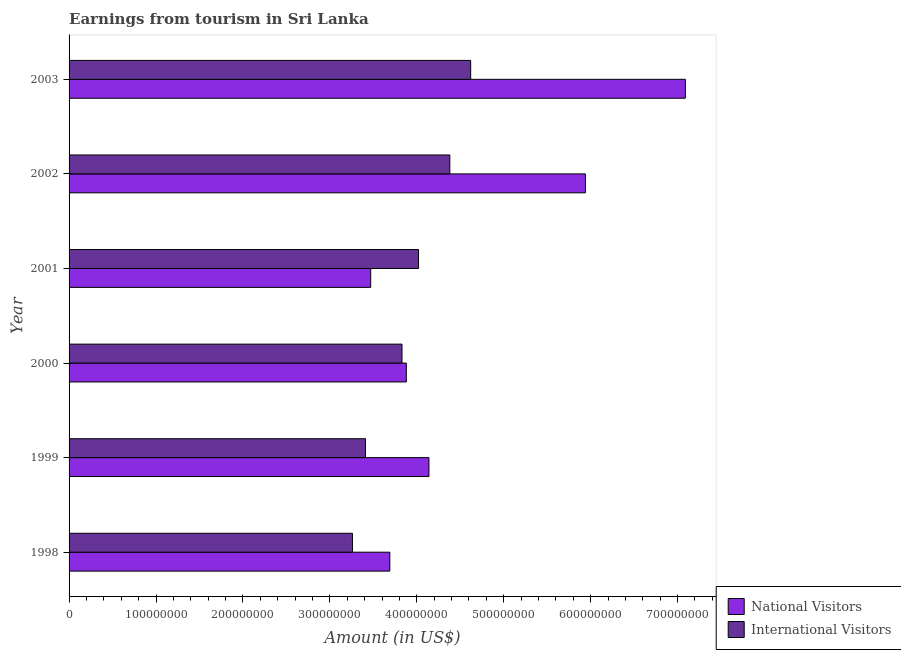How many different coloured bars are there?
Offer a terse response. 2. Are the number of bars per tick equal to the number of legend labels?
Provide a short and direct response. Yes. How many bars are there on the 3rd tick from the top?
Your answer should be very brief. 2. How many bars are there on the 2nd tick from the bottom?
Your answer should be compact. 2. What is the label of the 3rd group of bars from the top?
Your answer should be compact. 2001. What is the amount earned from international visitors in 2003?
Provide a succinct answer. 4.62e+08. Across all years, what is the maximum amount earned from international visitors?
Provide a succinct answer. 4.62e+08. Across all years, what is the minimum amount earned from international visitors?
Provide a short and direct response. 3.26e+08. In which year was the amount earned from national visitors maximum?
Make the answer very short. 2003. In which year was the amount earned from international visitors minimum?
Keep it short and to the point. 1998. What is the total amount earned from international visitors in the graph?
Give a very brief answer. 2.35e+09. What is the difference between the amount earned from international visitors in 2000 and that in 2001?
Provide a short and direct response. -1.90e+07. What is the difference between the amount earned from national visitors in 2003 and the amount earned from international visitors in 1998?
Give a very brief answer. 3.83e+08. What is the average amount earned from national visitors per year?
Give a very brief answer. 4.70e+08. In the year 2000, what is the difference between the amount earned from national visitors and amount earned from international visitors?
Make the answer very short. 5.00e+06. What is the ratio of the amount earned from national visitors in 1998 to that in 2001?
Your answer should be compact. 1.06. Is the amount earned from international visitors in 1998 less than that in 2001?
Give a very brief answer. Yes. Is the difference between the amount earned from international visitors in 2001 and 2003 greater than the difference between the amount earned from national visitors in 2001 and 2003?
Provide a succinct answer. Yes. What is the difference between the highest and the second highest amount earned from international visitors?
Your answer should be very brief. 2.40e+07. What is the difference between the highest and the lowest amount earned from national visitors?
Keep it short and to the point. 3.62e+08. Is the sum of the amount earned from international visitors in 2000 and 2001 greater than the maximum amount earned from national visitors across all years?
Offer a terse response. Yes. What does the 1st bar from the top in 2002 represents?
Ensure brevity in your answer.  International Visitors. What does the 2nd bar from the bottom in 2003 represents?
Give a very brief answer. International Visitors. Are all the bars in the graph horizontal?
Offer a very short reply. Yes. How many years are there in the graph?
Provide a short and direct response. 6. Are the values on the major ticks of X-axis written in scientific E-notation?
Provide a succinct answer. No. Where does the legend appear in the graph?
Ensure brevity in your answer.  Bottom right. How many legend labels are there?
Your answer should be very brief. 2. How are the legend labels stacked?
Offer a very short reply. Vertical. What is the title of the graph?
Give a very brief answer. Earnings from tourism in Sri Lanka. Does "Lower secondary education" appear as one of the legend labels in the graph?
Ensure brevity in your answer.  No. What is the label or title of the X-axis?
Make the answer very short. Amount (in US$). What is the label or title of the Y-axis?
Offer a terse response. Year. What is the Amount (in US$) of National Visitors in 1998?
Offer a terse response. 3.69e+08. What is the Amount (in US$) in International Visitors in 1998?
Offer a very short reply. 3.26e+08. What is the Amount (in US$) in National Visitors in 1999?
Give a very brief answer. 4.14e+08. What is the Amount (in US$) in International Visitors in 1999?
Ensure brevity in your answer.  3.41e+08. What is the Amount (in US$) in National Visitors in 2000?
Make the answer very short. 3.88e+08. What is the Amount (in US$) in International Visitors in 2000?
Ensure brevity in your answer.  3.83e+08. What is the Amount (in US$) of National Visitors in 2001?
Provide a short and direct response. 3.47e+08. What is the Amount (in US$) of International Visitors in 2001?
Your answer should be very brief. 4.02e+08. What is the Amount (in US$) in National Visitors in 2002?
Your response must be concise. 5.94e+08. What is the Amount (in US$) in International Visitors in 2002?
Ensure brevity in your answer.  4.38e+08. What is the Amount (in US$) in National Visitors in 2003?
Provide a succinct answer. 7.09e+08. What is the Amount (in US$) in International Visitors in 2003?
Provide a succinct answer. 4.62e+08. Across all years, what is the maximum Amount (in US$) in National Visitors?
Give a very brief answer. 7.09e+08. Across all years, what is the maximum Amount (in US$) of International Visitors?
Provide a short and direct response. 4.62e+08. Across all years, what is the minimum Amount (in US$) in National Visitors?
Give a very brief answer. 3.47e+08. Across all years, what is the minimum Amount (in US$) in International Visitors?
Keep it short and to the point. 3.26e+08. What is the total Amount (in US$) of National Visitors in the graph?
Offer a very short reply. 2.82e+09. What is the total Amount (in US$) of International Visitors in the graph?
Give a very brief answer. 2.35e+09. What is the difference between the Amount (in US$) of National Visitors in 1998 and that in 1999?
Provide a short and direct response. -4.50e+07. What is the difference between the Amount (in US$) of International Visitors in 1998 and that in 1999?
Provide a short and direct response. -1.50e+07. What is the difference between the Amount (in US$) in National Visitors in 1998 and that in 2000?
Keep it short and to the point. -1.90e+07. What is the difference between the Amount (in US$) in International Visitors in 1998 and that in 2000?
Give a very brief answer. -5.70e+07. What is the difference between the Amount (in US$) in National Visitors in 1998 and that in 2001?
Your answer should be compact. 2.20e+07. What is the difference between the Amount (in US$) in International Visitors in 1998 and that in 2001?
Offer a very short reply. -7.60e+07. What is the difference between the Amount (in US$) of National Visitors in 1998 and that in 2002?
Keep it short and to the point. -2.25e+08. What is the difference between the Amount (in US$) in International Visitors in 1998 and that in 2002?
Provide a short and direct response. -1.12e+08. What is the difference between the Amount (in US$) of National Visitors in 1998 and that in 2003?
Keep it short and to the point. -3.40e+08. What is the difference between the Amount (in US$) of International Visitors in 1998 and that in 2003?
Your response must be concise. -1.36e+08. What is the difference between the Amount (in US$) in National Visitors in 1999 and that in 2000?
Ensure brevity in your answer.  2.60e+07. What is the difference between the Amount (in US$) in International Visitors in 1999 and that in 2000?
Your answer should be very brief. -4.20e+07. What is the difference between the Amount (in US$) in National Visitors in 1999 and that in 2001?
Make the answer very short. 6.70e+07. What is the difference between the Amount (in US$) of International Visitors in 1999 and that in 2001?
Offer a terse response. -6.10e+07. What is the difference between the Amount (in US$) in National Visitors in 1999 and that in 2002?
Make the answer very short. -1.80e+08. What is the difference between the Amount (in US$) in International Visitors in 1999 and that in 2002?
Your answer should be very brief. -9.70e+07. What is the difference between the Amount (in US$) of National Visitors in 1999 and that in 2003?
Offer a terse response. -2.95e+08. What is the difference between the Amount (in US$) in International Visitors in 1999 and that in 2003?
Your response must be concise. -1.21e+08. What is the difference between the Amount (in US$) in National Visitors in 2000 and that in 2001?
Your response must be concise. 4.10e+07. What is the difference between the Amount (in US$) of International Visitors in 2000 and that in 2001?
Ensure brevity in your answer.  -1.90e+07. What is the difference between the Amount (in US$) in National Visitors in 2000 and that in 2002?
Provide a succinct answer. -2.06e+08. What is the difference between the Amount (in US$) of International Visitors in 2000 and that in 2002?
Provide a short and direct response. -5.50e+07. What is the difference between the Amount (in US$) in National Visitors in 2000 and that in 2003?
Offer a very short reply. -3.21e+08. What is the difference between the Amount (in US$) of International Visitors in 2000 and that in 2003?
Your answer should be very brief. -7.90e+07. What is the difference between the Amount (in US$) of National Visitors in 2001 and that in 2002?
Provide a short and direct response. -2.47e+08. What is the difference between the Amount (in US$) of International Visitors in 2001 and that in 2002?
Your answer should be compact. -3.60e+07. What is the difference between the Amount (in US$) of National Visitors in 2001 and that in 2003?
Give a very brief answer. -3.62e+08. What is the difference between the Amount (in US$) of International Visitors in 2001 and that in 2003?
Your answer should be compact. -6.00e+07. What is the difference between the Amount (in US$) in National Visitors in 2002 and that in 2003?
Your answer should be very brief. -1.15e+08. What is the difference between the Amount (in US$) of International Visitors in 2002 and that in 2003?
Give a very brief answer. -2.40e+07. What is the difference between the Amount (in US$) in National Visitors in 1998 and the Amount (in US$) in International Visitors in 1999?
Provide a succinct answer. 2.80e+07. What is the difference between the Amount (in US$) of National Visitors in 1998 and the Amount (in US$) of International Visitors in 2000?
Ensure brevity in your answer.  -1.40e+07. What is the difference between the Amount (in US$) in National Visitors in 1998 and the Amount (in US$) in International Visitors in 2001?
Offer a terse response. -3.30e+07. What is the difference between the Amount (in US$) of National Visitors in 1998 and the Amount (in US$) of International Visitors in 2002?
Provide a succinct answer. -6.90e+07. What is the difference between the Amount (in US$) of National Visitors in 1998 and the Amount (in US$) of International Visitors in 2003?
Your answer should be compact. -9.30e+07. What is the difference between the Amount (in US$) of National Visitors in 1999 and the Amount (in US$) of International Visitors in 2000?
Offer a very short reply. 3.10e+07. What is the difference between the Amount (in US$) of National Visitors in 1999 and the Amount (in US$) of International Visitors in 2002?
Provide a succinct answer. -2.40e+07. What is the difference between the Amount (in US$) of National Visitors in 1999 and the Amount (in US$) of International Visitors in 2003?
Keep it short and to the point. -4.80e+07. What is the difference between the Amount (in US$) of National Visitors in 2000 and the Amount (in US$) of International Visitors in 2001?
Keep it short and to the point. -1.40e+07. What is the difference between the Amount (in US$) of National Visitors in 2000 and the Amount (in US$) of International Visitors in 2002?
Your answer should be very brief. -5.00e+07. What is the difference between the Amount (in US$) in National Visitors in 2000 and the Amount (in US$) in International Visitors in 2003?
Give a very brief answer. -7.40e+07. What is the difference between the Amount (in US$) in National Visitors in 2001 and the Amount (in US$) in International Visitors in 2002?
Your answer should be compact. -9.10e+07. What is the difference between the Amount (in US$) of National Visitors in 2001 and the Amount (in US$) of International Visitors in 2003?
Provide a succinct answer. -1.15e+08. What is the difference between the Amount (in US$) of National Visitors in 2002 and the Amount (in US$) of International Visitors in 2003?
Offer a terse response. 1.32e+08. What is the average Amount (in US$) in National Visitors per year?
Your answer should be compact. 4.70e+08. What is the average Amount (in US$) of International Visitors per year?
Give a very brief answer. 3.92e+08. In the year 1998, what is the difference between the Amount (in US$) of National Visitors and Amount (in US$) of International Visitors?
Your response must be concise. 4.30e+07. In the year 1999, what is the difference between the Amount (in US$) of National Visitors and Amount (in US$) of International Visitors?
Your answer should be compact. 7.30e+07. In the year 2001, what is the difference between the Amount (in US$) in National Visitors and Amount (in US$) in International Visitors?
Keep it short and to the point. -5.50e+07. In the year 2002, what is the difference between the Amount (in US$) of National Visitors and Amount (in US$) of International Visitors?
Provide a short and direct response. 1.56e+08. In the year 2003, what is the difference between the Amount (in US$) of National Visitors and Amount (in US$) of International Visitors?
Your answer should be very brief. 2.47e+08. What is the ratio of the Amount (in US$) in National Visitors in 1998 to that in 1999?
Ensure brevity in your answer.  0.89. What is the ratio of the Amount (in US$) of International Visitors in 1998 to that in 1999?
Make the answer very short. 0.96. What is the ratio of the Amount (in US$) in National Visitors in 1998 to that in 2000?
Provide a succinct answer. 0.95. What is the ratio of the Amount (in US$) in International Visitors in 1998 to that in 2000?
Offer a terse response. 0.85. What is the ratio of the Amount (in US$) of National Visitors in 1998 to that in 2001?
Keep it short and to the point. 1.06. What is the ratio of the Amount (in US$) in International Visitors in 1998 to that in 2001?
Give a very brief answer. 0.81. What is the ratio of the Amount (in US$) in National Visitors in 1998 to that in 2002?
Offer a very short reply. 0.62. What is the ratio of the Amount (in US$) in International Visitors in 1998 to that in 2002?
Ensure brevity in your answer.  0.74. What is the ratio of the Amount (in US$) of National Visitors in 1998 to that in 2003?
Ensure brevity in your answer.  0.52. What is the ratio of the Amount (in US$) of International Visitors in 1998 to that in 2003?
Your answer should be very brief. 0.71. What is the ratio of the Amount (in US$) of National Visitors in 1999 to that in 2000?
Your answer should be compact. 1.07. What is the ratio of the Amount (in US$) in International Visitors in 1999 to that in 2000?
Offer a very short reply. 0.89. What is the ratio of the Amount (in US$) in National Visitors in 1999 to that in 2001?
Make the answer very short. 1.19. What is the ratio of the Amount (in US$) of International Visitors in 1999 to that in 2001?
Provide a succinct answer. 0.85. What is the ratio of the Amount (in US$) in National Visitors in 1999 to that in 2002?
Keep it short and to the point. 0.7. What is the ratio of the Amount (in US$) of International Visitors in 1999 to that in 2002?
Offer a terse response. 0.78. What is the ratio of the Amount (in US$) of National Visitors in 1999 to that in 2003?
Give a very brief answer. 0.58. What is the ratio of the Amount (in US$) of International Visitors in 1999 to that in 2003?
Make the answer very short. 0.74. What is the ratio of the Amount (in US$) of National Visitors in 2000 to that in 2001?
Provide a short and direct response. 1.12. What is the ratio of the Amount (in US$) of International Visitors in 2000 to that in 2001?
Offer a very short reply. 0.95. What is the ratio of the Amount (in US$) of National Visitors in 2000 to that in 2002?
Offer a terse response. 0.65. What is the ratio of the Amount (in US$) in International Visitors in 2000 to that in 2002?
Your answer should be compact. 0.87. What is the ratio of the Amount (in US$) in National Visitors in 2000 to that in 2003?
Provide a short and direct response. 0.55. What is the ratio of the Amount (in US$) in International Visitors in 2000 to that in 2003?
Offer a very short reply. 0.83. What is the ratio of the Amount (in US$) of National Visitors in 2001 to that in 2002?
Keep it short and to the point. 0.58. What is the ratio of the Amount (in US$) of International Visitors in 2001 to that in 2002?
Make the answer very short. 0.92. What is the ratio of the Amount (in US$) of National Visitors in 2001 to that in 2003?
Ensure brevity in your answer.  0.49. What is the ratio of the Amount (in US$) of International Visitors in 2001 to that in 2003?
Provide a succinct answer. 0.87. What is the ratio of the Amount (in US$) in National Visitors in 2002 to that in 2003?
Ensure brevity in your answer.  0.84. What is the ratio of the Amount (in US$) in International Visitors in 2002 to that in 2003?
Provide a succinct answer. 0.95. What is the difference between the highest and the second highest Amount (in US$) in National Visitors?
Offer a very short reply. 1.15e+08. What is the difference between the highest and the second highest Amount (in US$) of International Visitors?
Provide a succinct answer. 2.40e+07. What is the difference between the highest and the lowest Amount (in US$) in National Visitors?
Your response must be concise. 3.62e+08. What is the difference between the highest and the lowest Amount (in US$) of International Visitors?
Give a very brief answer. 1.36e+08. 